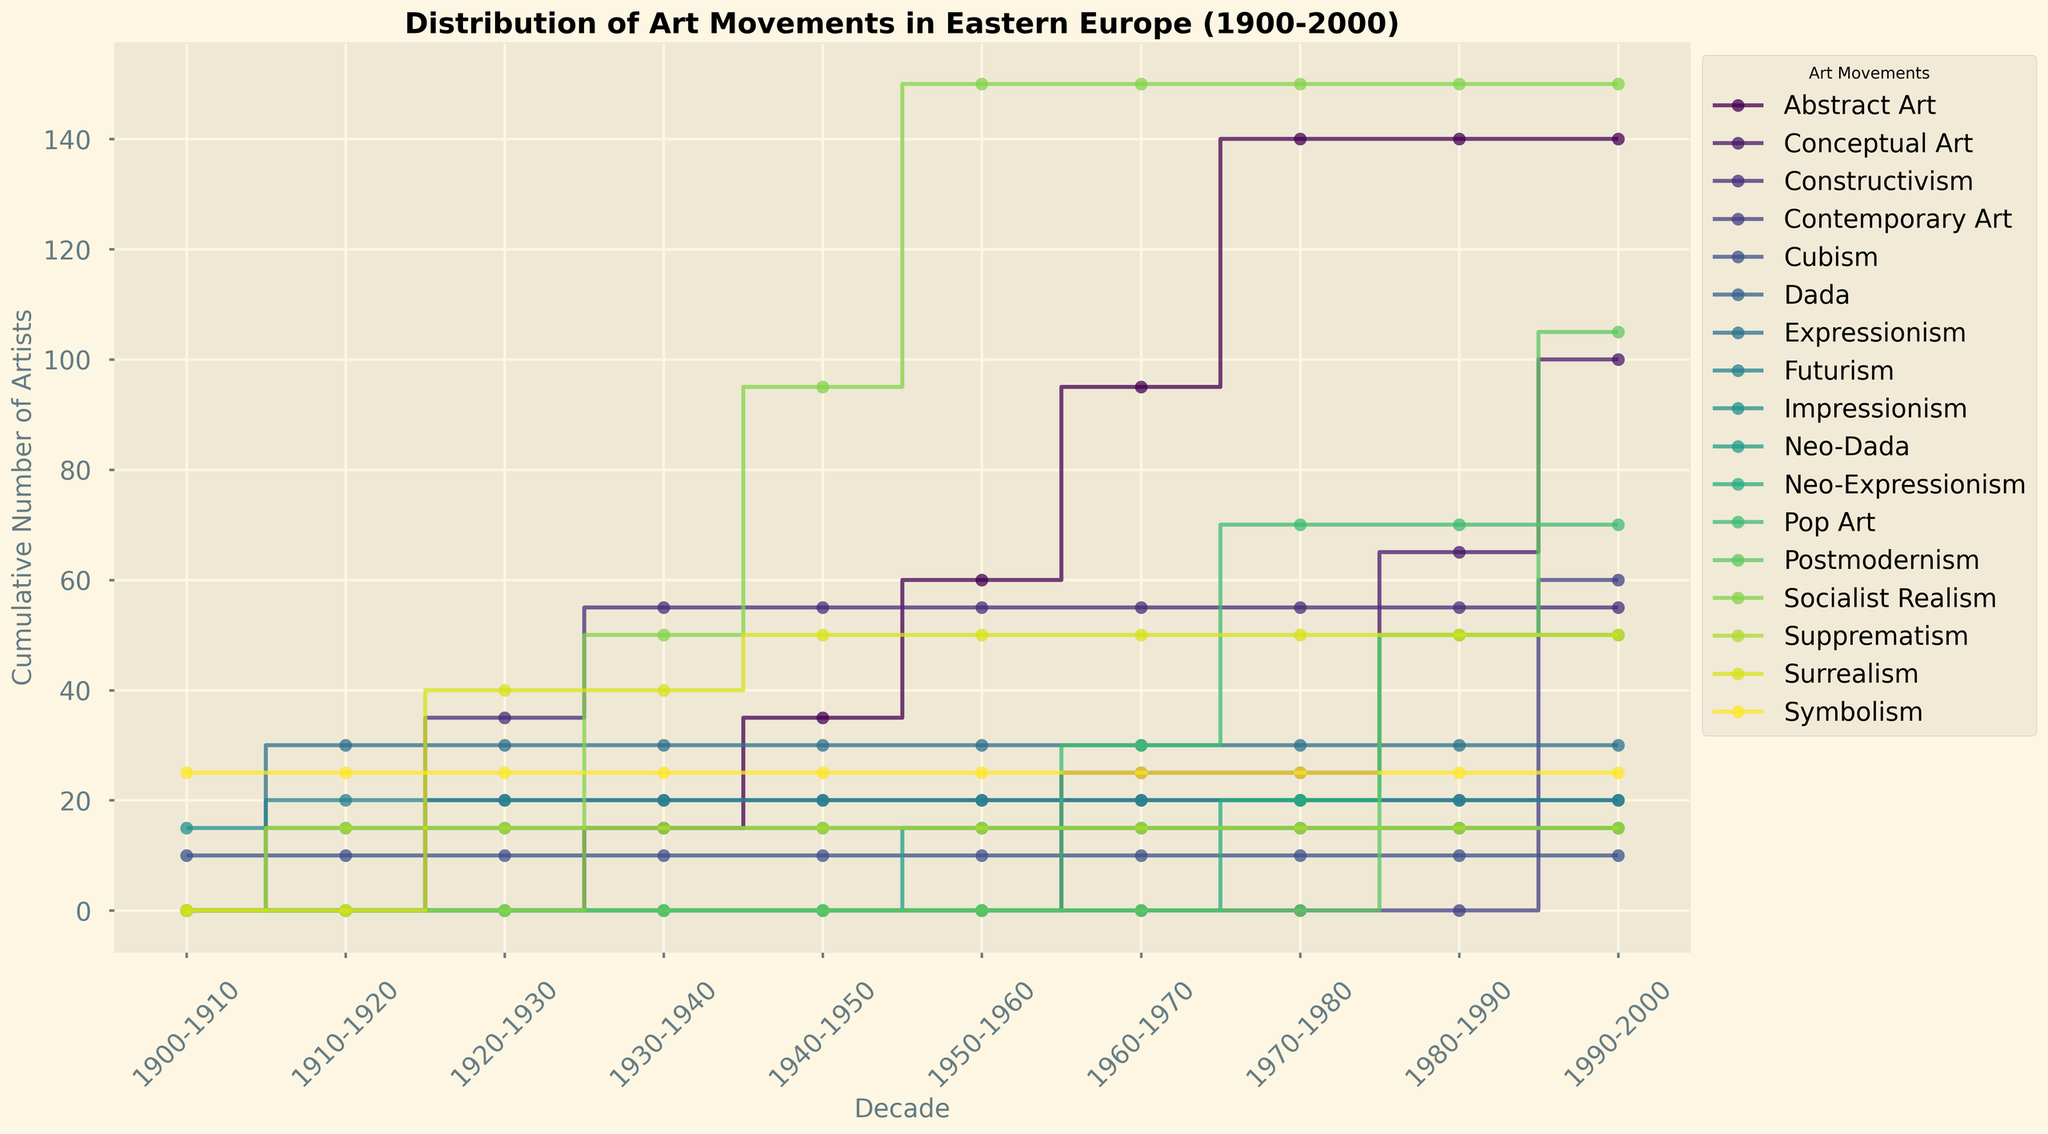What is the total number of artists in the 1950s? To find the total number of artists in the 1950s, sum the cumulative values at the 1950 mark for all art movements: Socialist Realism, Abstract Art, Neo-Dada.
Answer: 55 + 25 + 15 = 95 Which art movement has the highest cumulative number of artists by the end of the 1950s? Compare the cumulative number of artists for each art movement up to the end of the 1950s.
Answer: Socialist Realism Did Abstract Art or Pop Art have a larger number of artists during the 1970s? Compare the cumulative values of Abstract Art and Pop Art at the 1980 mark. Abstract Art: 45, Pop Art: 40.
Answer: Abstract Art How does the number of Postmodernism artists compare to Conceptual Art during the 1990s? Postmodernism cumulative number at the 2000 mark is 55 and for Conceptual Art it is 35.
Answer: Postmodernism has more artists Which decade saw the steepest increase in the number of Socialist Realism artists? Steepest increase refers to the largest jump in value. Consider the number increments between decades: 1930s to 1940s (50 to 45), 1940s to 1950s (45 to 55). The steepest increase is in the 1950s.
Answer: 1950s What is the cumulative number of Surrealism artists by the end of 1950? Sum the cumulative values of Surrealism up to the 1950s. Only considering the value before 1950 mark, it should be at the 1940s and 1950s combined: 40+10.
Answer: 50 Is there a decade where Expressionism had more artists than Futurism? Compare the cumulative values for Expressionism and Futurism across each relevant decade. Expressionism is greater in the 1910s.
Answer: Yes, 1910s Between Abstract Art and Constructivism, which had a higher growth rate in the 1930s? Calculate the growth rate as the difference between decades. Constructivism from 1920s to 1930s grew by 20 (from 20 to 0), Abstract Art grew by  15
Answer: Abstract Art Does the cumulative number of Constructivist artists by the end of 1940 exceed 30? Add the cumulative number of Constructivist artists up to the 1940s. From 1920-1930, 1930-1940: 35 + 20.
Answer: 55 What is the difference in the number of Dada artists between the 1920s and 1930s? Subtract the number of Dada artists in the 1930s from the number in the 1920s.
Answer: 20 - 0 = 20 